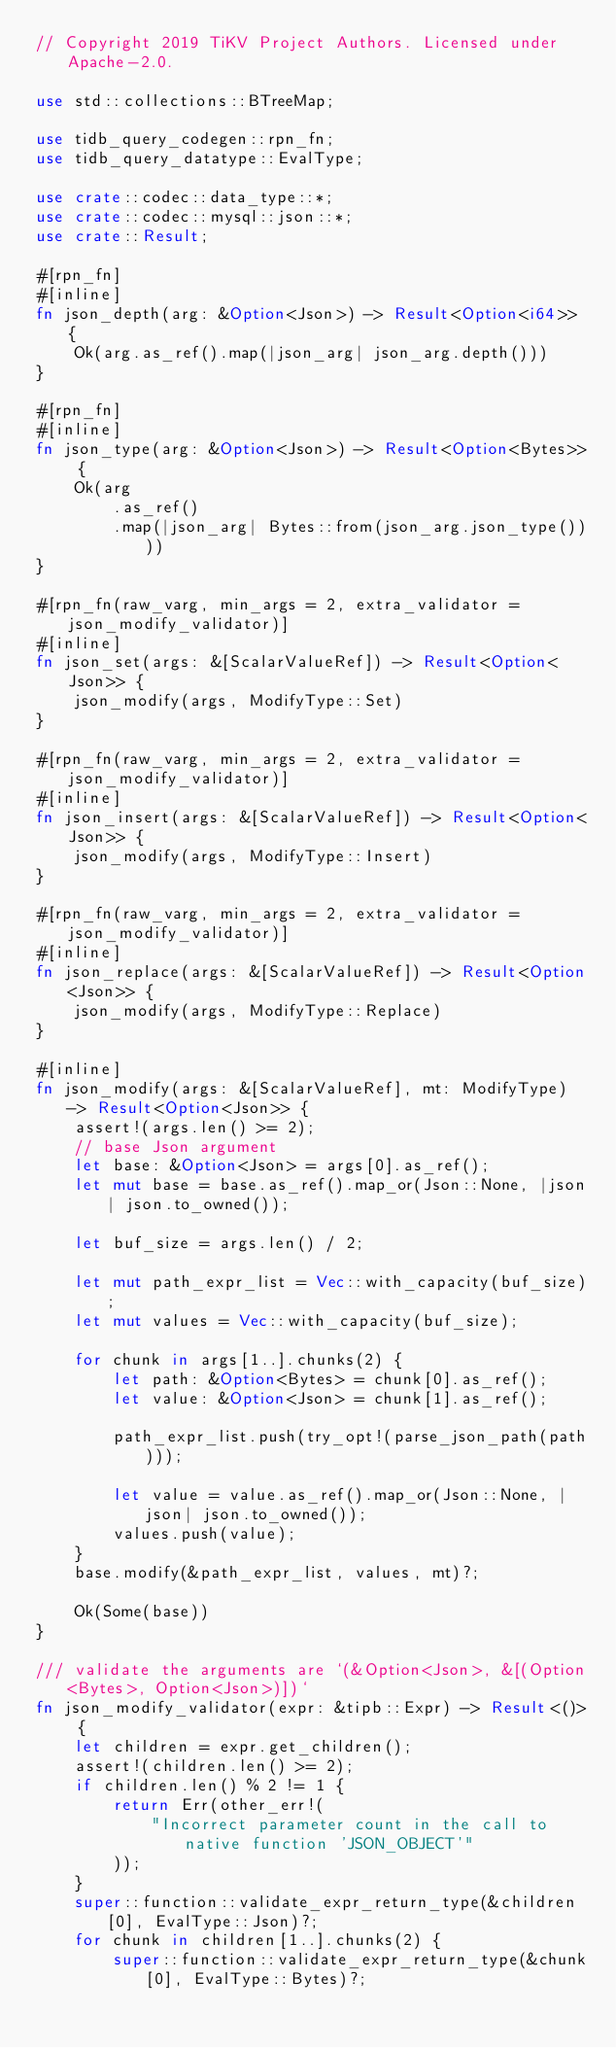Convert code to text. <code><loc_0><loc_0><loc_500><loc_500><_Rust_>// Copyright 2019 TiKV Project Authors. Licensed under Apache-2.0.

use std::collections::BTreeMap;

use tidb_query_codegen::rpn_fn;
use tidb_query_datatype::EvalType;

use crate::codec::data_type::*;
use crate::codec::mysql::json::*;
use crate::Result;

#[rpn_fn]
#[inline]
fn json_depth(arg: &Option<Json>) -> Result<Option<i64>> {
    Ok(arg.as_ref().map(|json_arg| json_arg.depth()))
}

#[rpn_fn]
#[inline]
fn json_type(arg: &Option<Json>) -> Result<Option<Bytes>> {
    Ok(arg
        .as_ref()
        .map(|json_arg| Bytes::from(json_arg.json_type())))
}

#[rpn_fn(raw_varg, min_args = 2, extra_validator = json_modify_validator)]
#[inline]
fn json_set(args: &[ScalarValueRef]) -> Result<Option<Json>> {
    json_modify(args, ModifyType::Set)
}

#[rpn_fn(raw_varg, min_args = 2, extra_validator = json_modify_validator)]
#[inline]
fn json_insert(args: &[ScalarValueRef]) -> Result<Option<Json>> {
    json_modify(args, ModifyType::Insert)
}

#[rpn_fn(raw_varg, min_args = 2, extra_validator = json_modify_validator)]
#[inline]
fn json_replace(args: &[ScalarValueRef]) -> Result<Option<Json>> {
    json_modify(args, ModifyType::Replace)
}

#[inline]
fn json_modify(args: &[ScalarValueRef], mt: ModifyType) -> Result<Option<Json>> {
    assert!(args.len() >= 2);
    // base Json argument
    let base: &Option<Json> = args[0].as_ref();
    let mut base = base.as_ref().map_or(Json::None, |json| json.to_owned());

    let buf_size = args.len() / 2;

    let mut path_expr_list = Vec::with_capacity(buf_size);
    let mut values = Vec::with_capacity(buf_size);

    for chunk in args[1..].chunks(2) {
        let path: &Option<Bytes> = chunk[0].as_ref();
        let value: &Option<Json> = chunk[1].as_ref();

        path_expr_list.push(try_opt!(parse_json_path(path)));

        let value = value.as_ref().map_or(Json::None, |json| json.to_owned());
        values.push(value);
    }
    base.modify(&path_expr_list, values, mt)?;

    Ok(Some(base))
}

/// validate the arguments are `(&Option<Json>, &[(Option<Bytes>, Option<Json>)])`
fn json_modify_validator(expr: &tipb::Expr) -> Result<()> {
    let children = expr.get_children();
    assert!(children.len() >= 2);
    if children.len() % 2 != 1 {
        return Err(other_err!(
            "Incorrect parameter count in the call to native function 'JSON_OBJECT'"
        ));
    }
    super::function::validate_expr_return_type(&children[0], EvalType::Json)?;
    for chunk in children[1..].chunks(2) {
        super::function::validate_expr_return_type(&chunk[0], EvalType::Bytes)?;</code> 